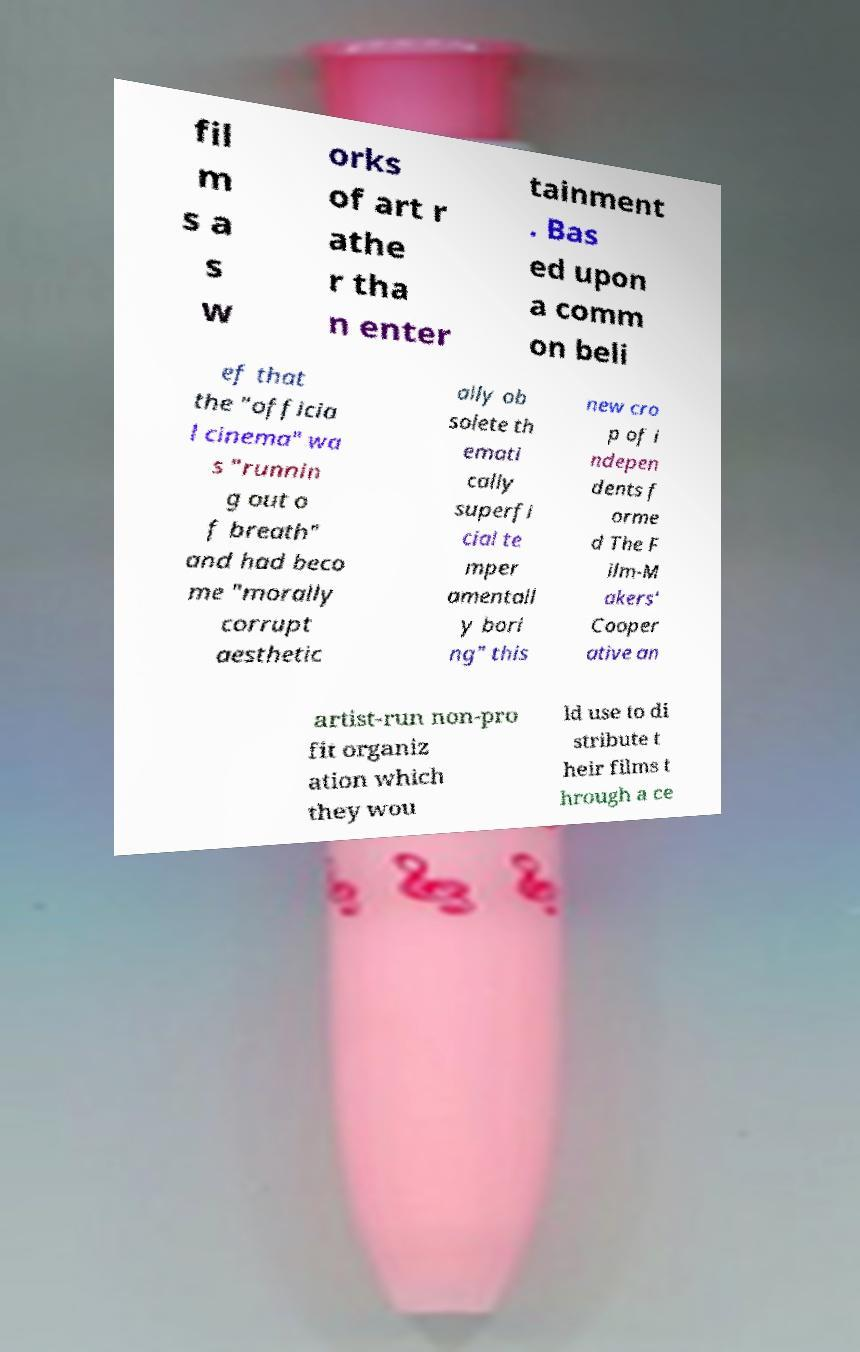I need the written content from this picture converted into text. Can you do that? fil m s a s w orks of art r athe r tha n enter tainment . Bas ed upon a comm on beli ef that the "officia l cinema" wa s "runnin g out o f breath" and had beco me "morally corrupt aesthetic ally ob solete th emati cally superfi cial te mper amentall y bori ng" this new cro p of i ndepen dents f orme d The F ilm-M akers' Cooper ative an artist-run non-pro fit organiz ation which they wou ld use to di stribute t heir films t hrough a ce 